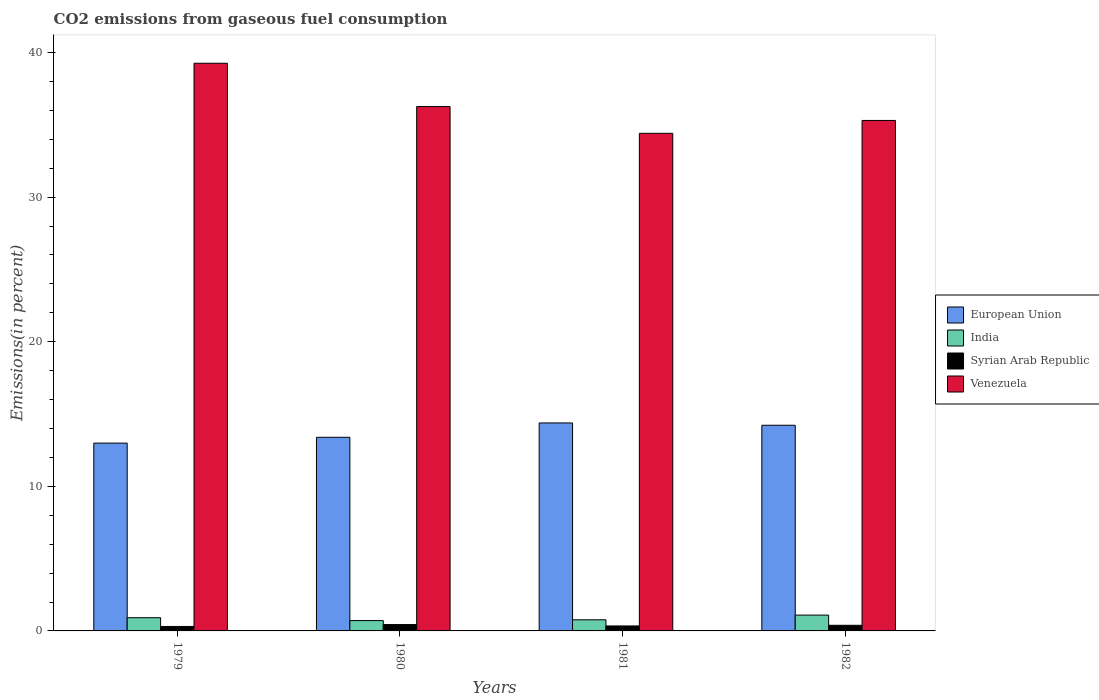What is the label of the 3rd group of bars from the left?
Offer a very short reply. 1981. In how many cases, is the number of bars for a given year not equal to the number of legend labels?
Ensure brevity in your answer.  0. What is the total CO2 emitted in Venezuela in 1981?
Your answer should be compact. 34.41. Across all years, what is the maximum total CO2 emitted in India?
Keep it short and to the point. 1.1. Across all years, what is the minimum total CO2 emitted in Syrian Arab Republic?
Your response must be concise. 0.31. In which year was the total CO2 emitted in European Union minimum?
Keep it short and to the point. 1979. What is the total total CO2 emitted in European Union in the graph?
Keep it short and to the point. 54.99. What is the difference between the total CO2 emitted in India in 1980 and that in 1982?
Your answer should be very brief. -0.38. What is the difference between the total CO2 emitted in European Union in 1981 and the total CO2 emitted in Venezuela in 1979?
Make the answer very short. -24.88. What is the average total CO2 emitted in India per year?
Keep it short and to the point. 0.87. In the year 1980, what is the difference between the total CO2 emitted in Venezuela and total CO2 emitted in Syrian Arab Republic?
Offer a very short reply. 35.82. What is the ratio of the total CO2 emitted in Venezuela in 1980 to that in 1982?
Provide a succinct answer. 1.03. Is the total CO2 emitted in Venezuela in 1981 less than that in 1982?
Provide a succinct answer. Yes. Is the difference between the total CO2 emitted in Venezuela in 1980 and 1982 greater than the difference between the total CO2 emitted in Syrian Arab Republic in 1980 and 1982?
Offer a terse response. Yes. What is the difference between the highest and the second highest total CO2 emitted in Venezuela?
Offer a terse response. 3. What is the difference between the highest and the lowest total CO2 emitted in Syrian Arab Republic?
Provide a succinct answer. 0.13. Is it the case that in every year, the sum of the total CO2 emitted in Venezuela and total CO2 emitted in Syrian Arab Republic is greater than the sum of total CO2 emitted in India and total CO2 emitted in European Union?
Provide a succinct answer. Yes. What does the 1st bar from the right in 1982 represents?
Your response must be concise. Venezuela. Is it the case that in every year, the sum of the total CO2 emitted in Syrian Arab Republic and total CO2 emitted in European Union is greater than the total CO2 emitted in India?
Ensure brevity in your answer.  Yes. Are all the bars in the graph horizontal?
Your response must be concise. No. How many years are there in the graph?
Give a very brief answer. 4. What is the difference between two consecutive major ticks on the Y-axis?
Provide a short and direct response. 10. Are the values on the major ticks of Y-axis written in scientific E-notation?
Provide a succinct answer. No. Does the graph contain any zero values?
Ensure brevity in your answer.  No. Does the graph contain grids?
Your response must be concise. No. Where does the legend appear in the graph?
Provide a short and direct response. Center right. How many legend labels are there?
Offer a very short reply. 4. What is the title of the graph?
Ensure brevity in your answer.  CO2 emissions from gaseous fuel consumption. Does "Sri Lanka" appear as one of the legend labels in the graph?
Offer a very short reply. No. What is the label or title of the Y-axis?
Give a very brief answer. Emissions(in percent). What is the Emissions(in percent) of European Union in 1979?
Give a very brief answer. 12.99. What is the Emissions(in percent) in India in 1979?
Your answer should be compact. 0.91. What is the Emissions(in percent) in Syrian Arab Republic in 1979?
Keep it short and to the point. 0.31. What is the Emissions(in percent) of Venezuela in 1979?
Give a very brief answer. 39.26. What is the Emissions(in percent) of European Union in 1980?
Offer a very short reply. 13.39. What is the Emissions(in percent) of India in 1980?
Offer a terse response. 0.71. What is the Emissions(in percent) of Syrian Arab Republic in 1980?
Ensure brevity in your answer.  0.44. What is the Emissions(in percent) of Venezuela in 1980?
Keep it short and to the point. 36.27. What is the Emissions(in percent) of European Union in 1981?
Offer a terse response. 14.38. What is the Emissions(in percent) of India in 1981?
Offer a very short reply. 0.77. What is the Emissions(in percent) of Syrian Arab Republic in 1981?
Offer a very short reply. 0.34. What is the Emissions(in percent) in Venezuela in 1981?
Offer a very short reply. 34.41. What is the Emissions(in percent) of European Union in 1982?
Offer a very short reply. 14.22. What is the Emissions(in percent) of India in 1982?
Provide a short and direct response. 1.1. What is the Emissions(in percent) in Syrian Arab Republic in 1982?
Your response must be concise. 0.39. What is the Emissions(in percent) of Venezuela in 1982?
Provide a succinct answer. 35.31. Across all years, what is the maximum Emissions(in percent) in European Union?
Give a very brief answer. 14.38. Across all years, what is the maximum Emissions(in percent) of India?
Make the answer very short. 1.1. Across all years, what is the maximum Emissions(in percent) of Syrian Arab Republic?
Provide a short and direct response. 0.44. Across all years, what is the maximum Emissions(in percent) of Venezuela?
Your answer should be very brief. 39.26. Across all years, what is the minimum Emissions(in percent) of European Union?
Offer a very short reply. 12.99. Across all years, what is the minimum Emissions(in percent) of India?
Your answer should be very brief. 0.71. Across all years, what is the minimum Emissions(in percent) in Syrian Arab Republic?
Offer a very short reply. 0.31. Across all years, what is the minimum Emissions(in percent) in Venezuela?
Ensure brevity in your answer.  34.41. What is the total Emissions(in percent) in European Union in the graph?
Make the answer very short. 54.99. What is the total Emissions(in percent) in India in the graph?
Provide a succinct answer. 3.49. What is the total Emissions(in percent) in Syrian Arab Republic in the graph?
Provide a short and direct response. 1.48. What is the total Emissions(in percent) in Venezuela in the graph?
Offer a very short reply. 145.25. What is the difference between the Emissions(in percent) in European Union in 1979 and that in 1980?
Offer a terse response. -0.4. What is the difference between the Emissions(in percent) in India in 1979 and that in 1980?
Ensure brevity in your answer.  0.2. What is the difference between the Emissions(in percent) in Syrian Arab Republic in 1979 and that in 1980?
Offer a terse response. -0.13. What is the difference between the Emissions(in percent) of Venezuela in 1979 and that in 1980?
Offer a very short reply. 3. What is the difference between the Emissions(in percent) in European Union in 1979 and that in 1981?
Provide a succinct answer. -1.4. What is the difference between the Emissions(in percent) of India in 1979 and that in 1981?
Your answer should be very brief. 0.14. What is the difference between the Emissions(in percent) of Syrian Arab Republic in 1979 and that in 1981?
Your answer should be very brief. -0.04. What is the difference between the Emissions(in percent) of Venezuela in 1979 and that in 1981?
Give a very brief answer. 4.85. What is the difference between the Emissions(in percent) of European Union in 1979 and that in 1982?
Give a very brief answer. -1.24. What is the difference between the Emissions(in percent) of India in 1979 and that in 1982?
Your answer should be very brief. -0.18. What is the difference between the Emissions(in percent) of Syrian Arab Republic in 1979 and that in 1982?
Keep it short and to the point. -0.08. What is the difference between the Emissions(in percent) in Venezuela in 1979 and that in 1982?
Ensure brevity in your answer.  3.96. What is the difference between the Emissions(in percent) in European Union in 1980 and that in 1981?
Ensure brevity in your answer.  -0.99. What is the difference between the Emissions(in percent) of India in 1980 and that in 1981?
Provide a short and direct response. -0.06. What is the difference between the Emissions(in percent) of Syrian Arab Republic in 1980 and that in 1981?
Give a very brief answer. 0.1. What is the difference between the Emissions(in percent) of Venezuela in 1980 and that in 1981?
Provide a short and direct response. 1.85. What is the difference between the Emissions(in percent) in European Union in 1980 and that in 1982?
Provide a short and direct response. -0.83. What is the difference between the Emissions(in percent) of India in 1980 and that in 1982?
Offer a very short reply. -0.38. What is the difference between the Emissions(in percent) of Syrian Arab Republic in 1980 and that in 1982?
Your response must be concise. 0.05. What is the difference between the Emissions(in percent) of Venezuela in 1980 and that in 1982?
Provide a succinct answer. 0.96. What is the difference between the Emissions(in percent) of European Union in 1981 and that in 1982?
Provide a short and direct response. 0.16. What is the difference between the Emissions(in percent) of India in 1981 and that in 1982?
Provide a short and direct response. -0.33. What is the difference between the Emissions(in percent) of Syrian Arab Republic in 1981 and that in 1982?
Offer a very short reply. -0.05. What is the difference between the Emissions(in percent) of Venezuela in 1981 and that in 1982?
Give a very brief answer. -0.89. What is the difference between the Emissions(in percent) of European Union in 1979 and the Emissions(in percent) of India in 1980?
Give a very brief answer. 12.27. What is the difference between the Emissions(in percent) in European Union in 1979 and the Emissions(in percent) in Syrian Arab Republic in 1980?
Ensure brevity in your answer.  12.55. What is the difference between the Emissions(in percent) of European Union in 1979 and the Emissions(in percent) of Venezuela in 1980?
Your answer should be very brief. -23.28. What is the difference between the Emissions(in percent) of India in 1979 and the Emissions(in percent) of Syrian Arab Republic in 1980?
Offer a very short reply. 0.47. What is the difference between the Emissions(in percent) in India in 1979 and the Emissions(in percent) in Venezuela in 1980?
Your answer should be very brief. -35.35. What is the difference between the Emissions(in percent) in Syrian Arab Republic in 1979 and the Emissions(in percent) in Venezuela in 1980?
Make the answer very short. -35.96. What is the difference between the Emissions(in percent) in European Union in 1979 and the Emissions(in percent) in India in 1981?
Ensure brevity in your answer.  12.22. What is the difference between the Emissions(in percent) in European Union in 1979 and the Emissions(in percent) in Syrian Arab Republic in 1981?
Keep it short and to the point. 12.64. What is the difference between the Emissions(in percent) in European Union in 1979 and the Emissions(in percent) in Venezuela in 1981?
Keep it short and to the point. -21.43. What is the difference between the Emissions(in percent) in India in 1979 and the Emissions(in percent) in Syrian Arab Republic in 1981?
Your answer should be very brief. 0.57. What is the difference between the Emissions(in percent) of India in 1979 and the Emissions(in percent) of Venezuela in 1981?
Offer a very short reply. -33.5. What is the difference between the Emissions(in percent) in Syrian Arab Republic in 1979 and the Emissions(in percent) in Venezuela in 1981?
Provide a succinct answer. -34.1. What is the difference between the Emissions(in percent) of European Union in 1979 and the Emissions(in percent) of India in 1982?
Ensure brevity in your answer.  11.89. What is the difference between the Emissions(in percent) in European Union in 1979 and the Emissions(in percent) in Syrian Arab Republic in 1982?
Your answer should be compact. 12.6. What is the difference between the Emissions(in percent) in European Union in 1979 and the Emissions(in percent) in Venezuela in 1982?
Offer a terse response. -22.32. What is the difference between the Emissions(in percent) in India in 1979 and the Emissions(in percent) in Syrian Arab Republic in 1982?
Offer a very short reply. 0.52. What is the difference between the Emissions(in percent) of India in 1979 and the Emissions(in percent) of Venezuela in 1982?
Your answer should be compact. -34.39. What is the difference between the Emissions(in percent) in Syrian Arab Republic in 1979 and the Emissions(in percent) in Venezuela in 1982?
Provide a short and direct response. -35. What is the difference between the Emissions(in percent) of European Union in 1980 and the Emissions(in percent) of India in 1981?
Provide a short and direct response. 12.62. What is the difference between the Emissions(in percent) in European Union in 1980 and the Emissions(in percent) in Syrian Arab Republic in 1981?
Provide a succinct answer. 13.05. What is the difference between the Emissions(in percent) in European Union in 1980 and the Emissions(in percent) in Venezuela in 1981?
Make the answer very short. -21.02. What is the difference between the Emissions(in percent) in India in 1980 and the Emissions(in percent) in Syrian Arab Republic in 1981?
Ensure brevity in your answer.  0.37. What is the difference between the Emissions(in percent) in India in 1980 and the Emissions(in percent) in Venezuela in 1981?
Your answer should be compact. -33.7. What is the difference between the Emissions(in percent) of Syrian Arab Republic in 1980 and the Emissions(in percent) of Venezuela in 1981?
Offer a very short reply. -33.97. What is the difference between the Emissions(in percent) in European Union in 1980 and the Emissions(in percent) in India in 1982?
Provide a succinct answer. 12.3. What is the difference between the Emissions(in percent) of European Union in 1980 and the Emissions(in percent) of Syrian Arab Republic in 1982?
Provide a short and direct response. 13. What is the difference between the Emissions(in percent) in European Union in 1980 and the Emissions(in percent) in Venezuela in 1982?
Offer a terse response. -21.91. What is the difference between the Emissions(in percent) of India in 1980 and the Emissions(in percent) of Syrian Arab Republic in 1982?
Keep it short and to the point. 0.33. What is the difference between the Emissions(in percent) in India in 1980 and the Emissions(in percent) in Venezuela in 1982?
Your answer should be compact. -34.59. What is the difference between the Emissions(in percent) in Syrian Arab Republic in 1980 and the Emissions(in percent) in Venezuela in 1982?
Ensure brevity in your answer.  -34.86. What is the difference between the Emissions(in percent) in European Union in 1981 and the Emissions(in percent) in India in 1982?
Ensure brevity in your answer.  13.29. What is the difference between the Emissions(in percent) of European Union in 1981 and the Emissions(in percent) of Syrian Arab Republic in 1982?
Your response must be concise. 13.99. What is the difference between the Emissions(in percent) of European Union in 1981 and the Emissions(in percent) of Venezuela in 1982?
Keep it short and to the point. -20.92. What is the difference between the Emissions(in percent) of India in 1981 and the Emissions(in percent) of Syrian Arab Republic in 1982?
Offer a terse response. 0.38. What is the difference between the Emissions(in percent) in India in 1981 and the Emissions(in percent) in Venezuela in 1982?
Your answer should be compact. -34.54. What is the difference between the Emissions(in percent) in Syrian Arab Republic in 1981 and the Emissions(in percent) in Venezuela in 1982?
Give a very brief answer. -34.96. What is the average Emissions(in percent) of European Union per year?
Provide a short and direct response. 13.75. What is the average Emissions(in percent) in India per year?
Provide a succinct answer. 0.87. What is the average Emissions(in percent) in Syrian Arab Republic per year?
Keep it short and to the point. 0.37. What is the average Emissions(in percent) of Venezuela per year?
Provide a succinct answer. 36.31. In the year 1979, what is the difference between the Emissions(in percent) of European Union and Emissions(in percent) of India?
Give a very brief answer. 12.08. In the year 1979, what is the difference between the Emissions(in percent) of European Union and Emissions(in percent) of Syrian Arab Republic?
Give a very brief answer. 12.68. In the year 1979, what is the difference between the Emissions(in percent) in European Union and Emissions(in percent) in Venezuela?
Keep it short and to the point. -26.27. In the year 1979, what is the difference between the Emissions(in percent) of India and Emissions(in percent) of Syrian Arab Republic?
Offer a terse response. 0.6. In the year 1979, what is the difference between the Emissions(in percent) of India and Emissions(in percent) of Venezuela?
Keep it short and to the point. -38.35. In the year 1979, what is the difference between the Emissions(in percent) in Syrian Arab Republic and Emissions(in percent) in Venezuela?
Offer a terse response. -38.95. In the year 1980, what is the difference between the Emissions(in percent) in European Union and Emissions(in percent) in India?
Make the answer very short. 12.68. In the year 1980, what is the difference between the Emissions(in percent) of European Union and Emissions(in percent) of Syrian Arab Republic?
Keep it short and to the point. 12.95. In the year 1980, what is the difference between the Emissions(in percent) in European Union and Emissions(in percent) in Venezuela?
Provide a short and direct response. -22.87. In the year 1980, what is the difference between the Emissions(in percent) of India and Emissions(in percent) of Syrian Arab Republic?
Your answer should be compact. 0.27. In the year 1980, what is the difference between the Emissions(in percent) of India and Emissions(in percent) of Venezuela?
Provide a short and direct response. -35.55. In the year 1980, what is the difference between the Emissions(in percent) of Syrian Arab Republic and Emissions(in percent) of Venezuela?
Your answer should be very brief. -35.82. In the year 1981, what is the difference between the Emissions(in percent) in European Union and Emissions(in percent) in India?
Make the answer very short. 13.61. In the year 1981, what is the difference between the Emissions(in percent) in European Union and Emissions(in percent) in Syrian Arab Republic?
Provide a succinct answer. 14.04. In the year 1981, what is the difference between the Emissions(in percent) of European Union and Emissions(in percent) of Venezuela?
Offer a very short reply. -20.03. In the year 1981, what is the difference between the Emissions(in percent) in India and Emissions(in percent) in Syrian Arab Republic?
Provide a succinct answer. 0.43. In the year 1981, what is the difference between the Emissions(in percent) of India and Emissions(in percent) of Venezuela?
Provide a succinct answer. -33.64. In the year 1981, what is the difference between the Emissions(in percent) in Syrian Arab Republic and Emissions(in percent) in Venezuela?
Offer a terse response. -34.07. In the year 1982, what is the difference between the Emissions(in percent) of European Union and Emissions(in percent) of India?
Your answer should be compact. 13.13. In the year 1982, what is the difference between the Emissions(in percent) of European Union and Emissions(in percent) of Syrian Arab Republic?
Give a very brief answer. 13.83. In the year 1982, what is the difference between the Emissions(in percent) of European Union and Emissions(in percent) of Venezuela?
Your answer should be very brief. -21.08. In the year 1982, what is the difference between the Emissions(in percent) of India and Emissions(in percent) of Syrian Arab Republic?
Ensure brevity in your answer.  0.71. In the year 1982, what is the difference between the Emissions(in percent) in India and Emissions(in percent) in Venezuela?
Offer a terse response. -34.21. In the year 1982, what is the difference between the Emissions(in percent) in Syrian Arab Republic and Emissions(in percent) in Venezuela?
Offer a terse response. -34.92. What is the ratio of the Emissions(in percent) of European Union in 1979 to that in 1980?
Make the answer very short. 0.97. What is the ratio of the Emissions(in percent) of India in 1979 to that in 1980?
Provide a succinct answer. 1.28. What is the ratio of the Emissions(in percent) of Syrian Arab Republic in 1979 to that in 1980?
Make the answer very short. 0.7. What is the ratio of the Emissions(in percent) in Venezuela in 1979 to that in 1980?
Provide a short and direct response. 1.08. What is the ratio of the Emissions(in percent) of European Union in 1979 to that in 1981?
Your response must be concise. 0.9. What is the ratio of the Emissions(in percent) of India in 1979 to that in 1981?
Offer a very short reply. 1.19. What is the ratio of the Emissions(in percent) of Syrian Arab Republic in 1979 to that in 1981?
Offer a terse response. 0.9. What is the ratio of the Emissions(in percent) in Venezuela in 1979 to that in 1981?
Give a very brief answer. 1.14. What is the ratio of the Emissions(in percent) in European Union in 1979 to that in 1982?
Provide a succinct answer. 0.91. What is the ratio of the Emissions(in percent) of India in 1979 to that in 1982?
Your answer should be compact. 0.83. What is the ratio of the Emissions(in percent) in Syrian Arab Republic in 1979 to that in 1982?
Offer a terse response. 0.79. What is the ratio of the Emissions(in percent) in Venezuela in 1979 to that in 1982?
Make the answer very short. 1.11. What is the ratio of the Emissions(in percent) in India in 1980 to that in 1981?
Keep it short and to the point. 0.93. What is the ratio of the Emissions(in percent) in Syrian Arab Republic in 1980 to that in 1981?
Provide a short and direct response. 1.28. What is the ratio of the Emissions(in percent) in Venezuela in 1980 to that in 1981?
Your answer should be compact. 1.05. What is the ratio of the Emissions(in percent) of European Union in 1980 to that in 1982?
Give a very brief answer. 0.94. What is the ratio of the Emissions(in percent) of India in 1980 to that in 1982?
Offer a terse response. 0.65. What is the ratio of the Emissions(in percent) in Syrian Arab Republic in 1980 to that in 1982?
Offer a very short reply. 1.13. What is the ratio of the Emissions(in percent) of Venezuela in 1980 to that in 1982?
Make the answer very short. 1.03. What is the ratio of the Emissions(in percent) in European Union in 1981 to that in 1982?
Your answer should be compact. 1.01. What is the ratio of the Emissions(in percent) in India in 1981 to that in 1982?
Your response must be concise. 0.7. What is the ratio of the Emissions(in percent) of Syrian Arab Republic in 1981 to that in 1982?
Ensure brevity in your answer.  0.88. What is the ratio of the Emissions(in percent) of Venezuela in 1981 to that in 1982?
Give a very brief answer. 0.97. What is the difference between the highest and the second highest Emissions(in percent) in European Union?
Provide a succinct answer. 0.16. What is the difference between the highest and the second highest Emissions(in percent) of India?
Offer a very short reply. 0.18. What is the difference between the highest and the second highest Emissions(in percent) in Syrian Arab Republic?
Offer a very short reply. 0.05. What is the difference between the highest and the second highest Emissions(in percent) of Venezuela?
Provide a succinct answer. 3. What is the difference between the highest and the lowest Emissions(in percent) of European Union?
Keep it short and to the point. 1.4. What is the difference between the highest and the lowest Emissions(in percent) of India?
Your response must be concise. 0.38. What is the difference between the highest and the lowest Emissions(in percent) of Syrian Arab Republic?
Ensure brevity in your answer.  0.13. What is the difference between the highest and the lowest Emissions(in percent) of Venezuela?
Offer a terse response. 4.85. 